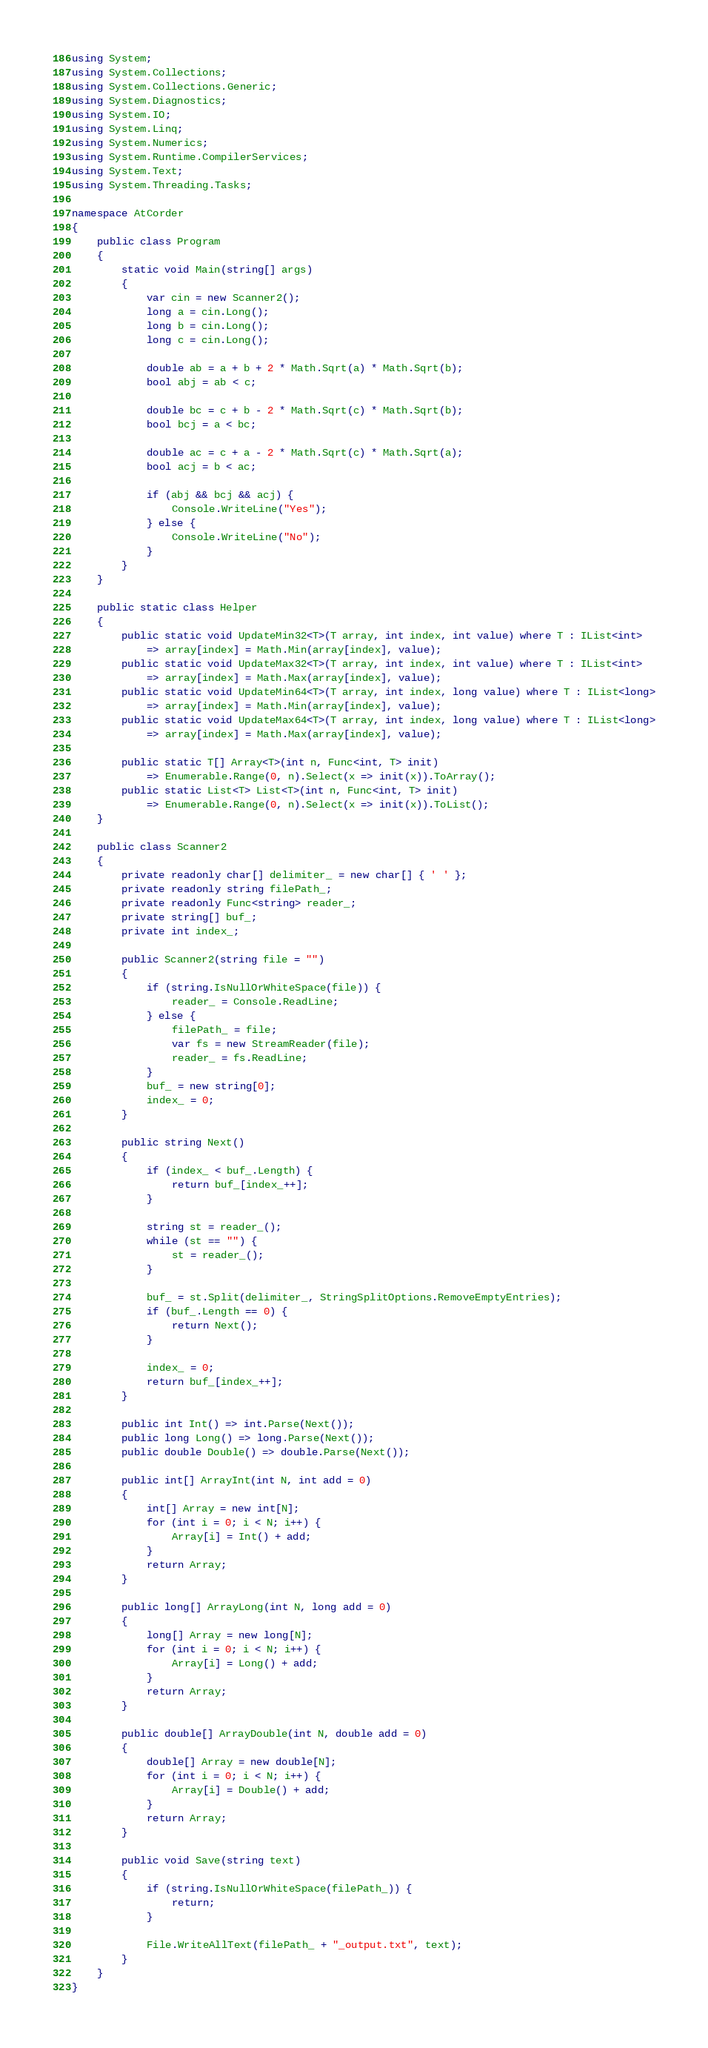<code> <loc_0><loc_0><loc_500><loc_500><_C#_>using System;
using System.Collections;
using System.Collections.Generic;
using System.Diagnostics;
using System.IO;
using System.Linq;
using System.Numerics;
using System.Runtime.CompilerServices;
using System.Text;
using System.Threading.Tasks;

namespace AtCorder
{
	public class Program
	{
		static void Main(string[] args)
		{
			var cin = new Scanner2();
			long a = cin.Long();
			long b = cin.Long();
			long c = cin.Long();

			double ab = a + b + 2 * Math.Sqrt(a) * Math.Sqrt(b);
			bool abj = ab < c;

			double bc = c + b - 2 * Math.Sqrt(c) * Math.Sqrt(b);
			bool bcj = a < bc;

			double ac = c + a - 2 * Math.Sqrt(c) * Math.Sqrt(a);
			bool acj = b < ac;

			if (abj && bcj && acj) {
				Console.WriteLine("Yes");
			} else {
				Console.WriteLine("No");
			}
		}
	}

	public static class Helper
	{
		public static void UpdateMin32<T>(T array, int index, int value) where T : IList<int>
			=> array[index] = Math.Min(array[index], value);
		public static void UpdateMax32<T>(T array, int index, int value) where T : IList<int>
			=> array[index] = Math.Max(array[index], value);
		public static void UpdateMin64<T>(T array, int index, long value) where T : IList<long>
			=> array[index] = Math.Min(array[index], value);
		public static void UpdateMax64<T>(T array, int index, long value) where T : IList<long>
			=> array[index] = Math.Max(array[index], value);

		public static T[] Array<T>(int n, Func<int, T> init)
			=> Enumerable.Range(0, n).Select(x => init(x)).ToArray();
		public static List<T> List<T>(int n, Func<int, T> init)
			=> Enumerable.Range(0, n).Select(x => init(x)).ToList();
	}

	public class Scanner2
	{
		private readonly char[] delimiter_ = new char[] { ' ' };
		private readonly string filePath_;
		private readonly Func<string> reader_;
		private string[] buf_;
		private int index_;

		public Scanner2(string file = "")
		{
			if (string.IsNullOrWhiteSpace(file)) {
				reader_ = Console.ReadLine;
			} else {
				filePath_ = file;
				var fs = new StreamReader(file);
				reader_ = fs.ReadLine;
			}
			buf_ = new string[0];
			index_ = 0;
		}

		public string Next()
		{
			if (index_ < buf_.Length) {
				return buf_[index_++];
			}

			string st = reader_();
			while (st == "") {
				st = reader_();
			}

			buf_ = st.Split(delimiter_, StringSplitOptions.RemoveEmptyEntries);
			if (buf_.Length == 0) {
				return Next();
			}

			index_ = 0;
			return buf_[index_++];
		}

		public int Int() => int.Parse(Next());
		public long Long() => long.Parse(Next());
		public double Double() => double.Parse(Next());

		public int[] ArrayInt(int N, int add = 0)
		{
			int[] Array = new int[N];
			for (int i = 0; i < N; i++) {
				Array[i] = Int() + add;
			}
			return Array;
		}

		public long[] ArrayLong(int N, long add = 0)
		{
			long[] Array = new long[N];
			for (int i = 0; i < N; i++) {
				Array[i] = Long() + add;
			}
			return Array;
		}

		public double[] ArrayDouble(int N, double add = 0)
		{
			double[] Array = new double[N];
			for (int i = 0; i < N; i++) {
				Array[i] = Double() + add;
			}
			return Array;
		}

		public void Save(string text)
		{
			if (string.IsNullOrWhiteSpace(filePath_)) {
				return;
			}

			File.WriteAllText(filePath_ + "_output.txt", text);
		}
	}
}</code> 